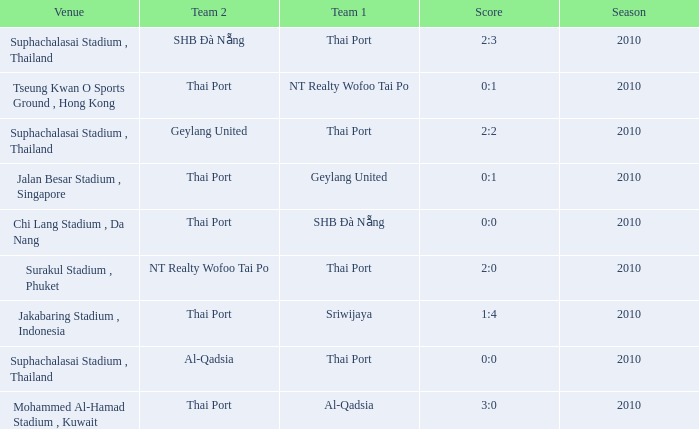What was the score for the game in which Al-Qadsia was Team 2? 0:0. 